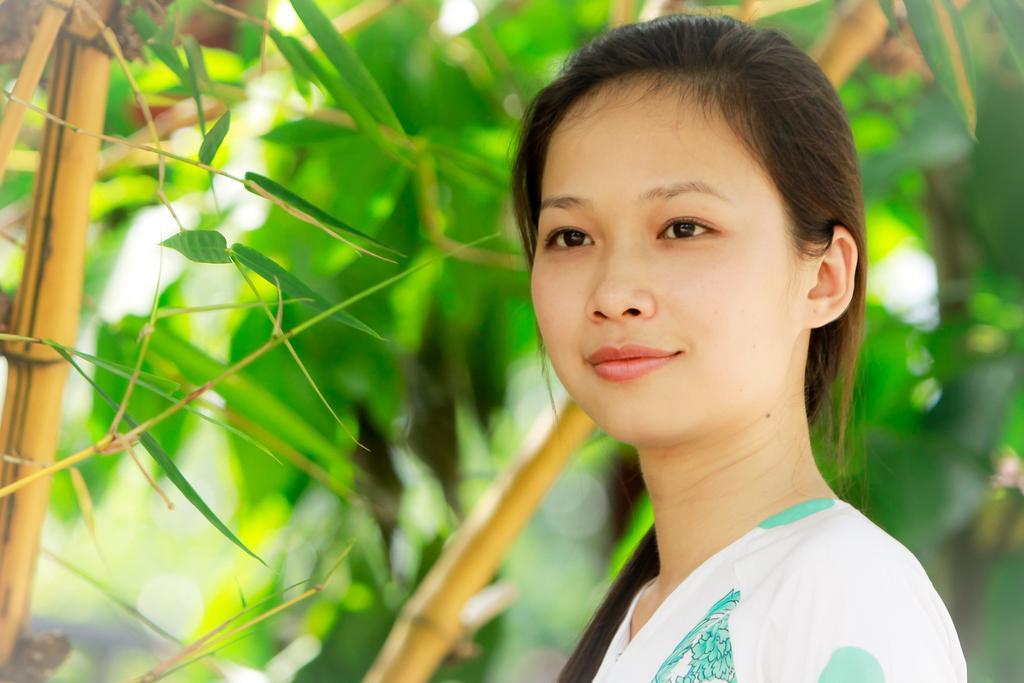Can you describe this image briefly? In this image there is a lady in the right. In the background there are trees. The background is blurry. 